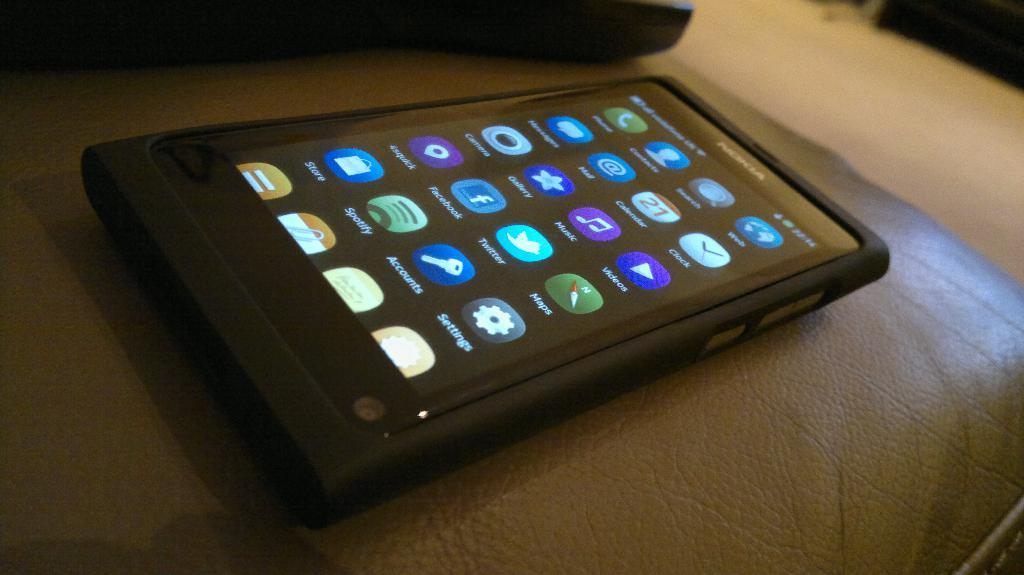Provide a one-sentence caption for the provided image. Black phone with the app called Settings on the bottom right. 